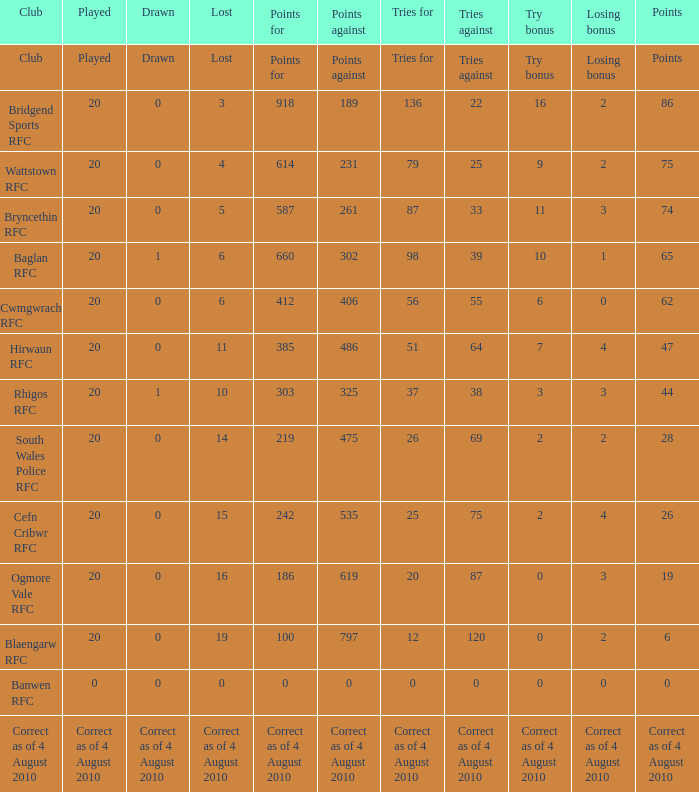Could you parse the entire table? {'header': ['Club', 'Played', 'Drawn', 'Lost', 'Points for', 'Points against', 'Tries for', 'Tries against', 'Try bonus', 'Losing bonus', 'Points'], 'rows': [['Club', 'Played', 'Drawn', 'Lost', 'Points for', 'Points against', 'Tries for', 'Tries against', 'Try bonus', 'Losing bonus', 'Points'], ['Bridgend Sports RFC', '20', '0', '3', '918', '189', '136', '22', '16', '2', '86'], ['Wattstown RFC', '20', '0', '4', '614', '231', '79', '25', '9', '2', '75'], ['Bryncethin RFC', '20', '0', '5', '587', '261', '87', '33', '11', '3', '74'], ['Baglan RFC', '20', '1', '6', '660', '302', '98', '39', '10', '1', '65'], ['Cwmgwrach RFC', '20', '0', '6', '412', '406', '56', '55', '6', '0', '62'], ['Hirwaun RFC', '20', '0', '11', '385', '486', '51', '64', '7', '4', '47'], ['Rhigos RFC', '20', '1', '10', '303', '325', '37', '38', '3', '3', '44'], ['South Wales Police RFC', '20', '0', '14', '219', '475', '26', '69', '2', '2', '28'], ['Cefn Cribwr RFC', '20', '0', '15', '242', '535', '25', '75', '2', '4', '26'], ['Ogmore Vale RFC', '20', '0', '16', '186', '619', '20', '87', '0', '3', '19'], ['Blaengarw RFC', '20', '0', '19', '100', '797', '12', '120', '0', '2', '6'], ['Banwen RFC', '0', '0', '0', '0', '0', '0', '0', '0', '0', '0'], ['Correct as of 4 August 2010', 'Correct as of 4 August 2010', 'Correct as of 4 August 2010', 'Correct as of 4 August 2010', 'Correct as of 4 August 2010', 'Correct as of 4 August 2010', 'Correct as of 4 August 2010', 'Correct as of 4 August 2010', 'Correct as of 4 August 2010', 'Correct as of 4 August 2010', 'Correct as of 4 August 2010']]} What is drawn when the club is hirwaun rfc? 0.0. 